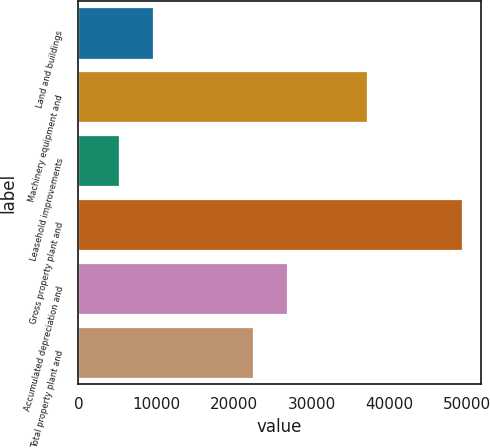Convert chart. <chart><loc_0><loc_0><loc_500><loc_500><bar_chart><fcel>Land and buildings<fcel>Machinery equipment and<fcel>Leasehold improvements<fcel>Gross property plant and<fcel>Accumulated depreciation and<fcel>Total property plant and<nl><fcel>9662.4<fcel>37038<fcel>5263<fcel>49257<fcel>26870.4<fcel>22471<nl></chart> 